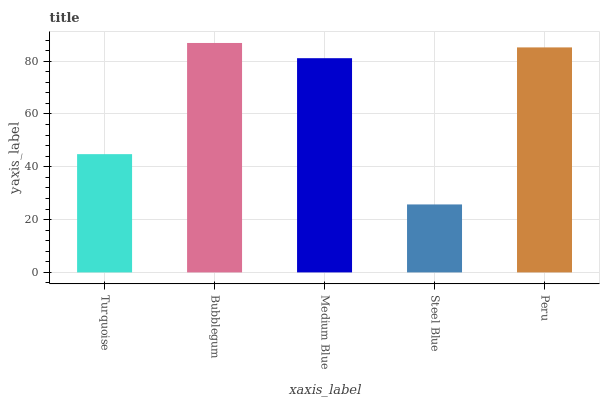Is Steel Blue the minimum?
Answer yes or no. Yes. Is Bubblegum the maximum?
Answer yes or no. Yes. Is Medium Blue the minimum?
Answer yes or no. No. Is Medium Blue the maximum?
Answer yes or no. No. Is Bubblegum greater than Medium Blue?
Answer yes or no. Yes. Is Medium Blue less than Bubblegum?
Answer yes or no. Yes. Is Medium Blue greater than Bubblegum?
Answer yes or no. No. Is Bubblegum less than Medium Blue?
Answer yes or no. No. Is Medium Blue the high median?
Answer yes or no. Yes. Is Medium Blue the low median?
Answer yes or no. Yes. Is Bubblegum the high median?
Answer yes or no. No. Is Turquoise the low median?
Answer yes or no. No. 